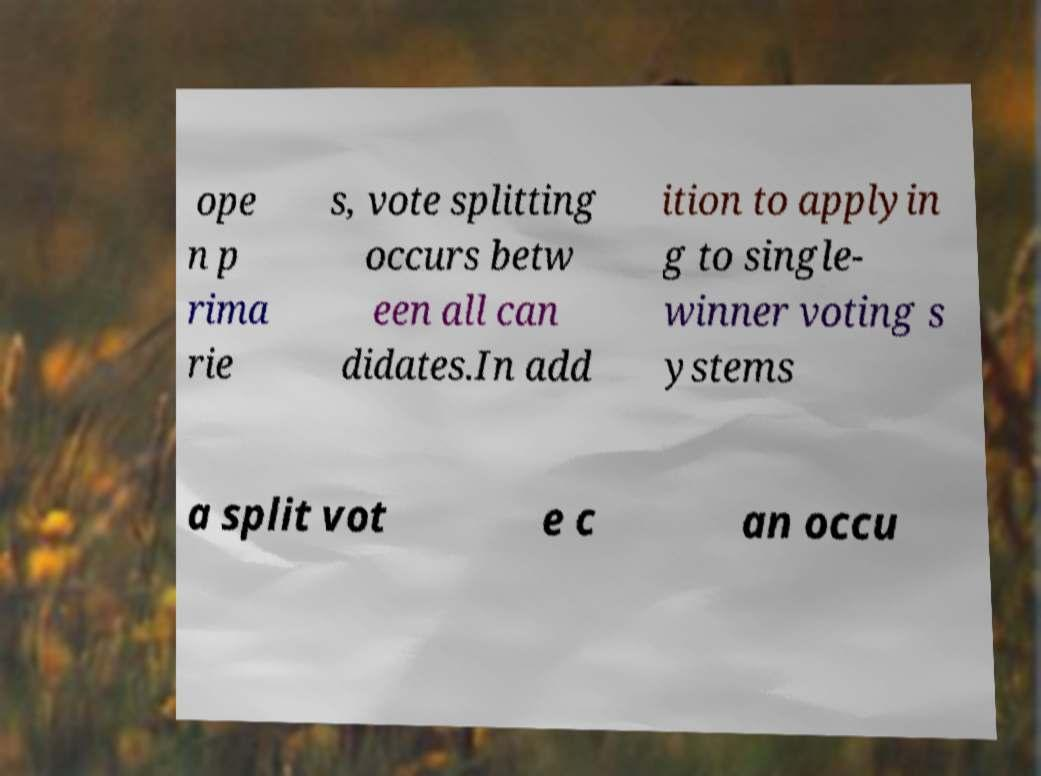Can you accurately transcribe the text from the provided image for me? The visible text in the image is: 'open primaries, vote splitting occurs between all candidates. In addition to applying to single-winner voting systems a split vote can occur'. The text seems to address voting strategies or election types, possibly discussing the implications of open primaries on vote distribution. 